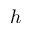Convert formula to latex. <formula><loc_0><loc_0><loc_500><loc_500>h</formula> 